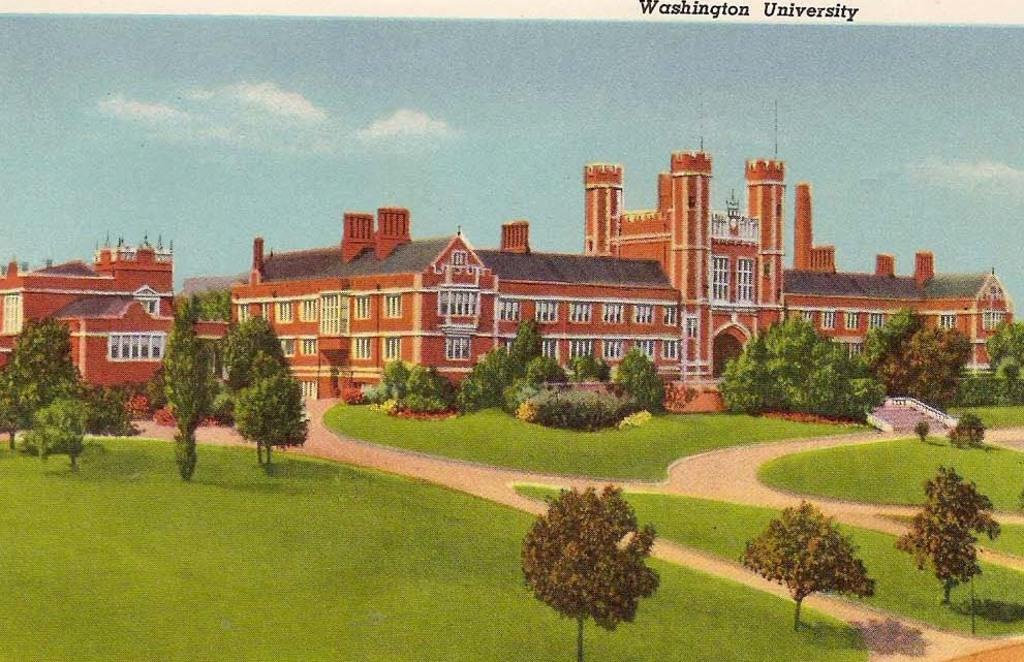What type of vegetation can be seen in the image? There are trees in the image. What is on the ground in the image? There is grass on the ground in the image. What type of structure is present in the image? There is a building in the image. What is the color of the building? The building is red in color. What can be seen in the background of the image? There is a sky visible in the background of the image. Can you see your dad smoking a cigarette in the image? There is no person, including a dad, present in the image, and therefore no such activity can be observed. What type of home is shown in the image? The image does not depict a home; it features include trees, grass, a red building, and a sky. 